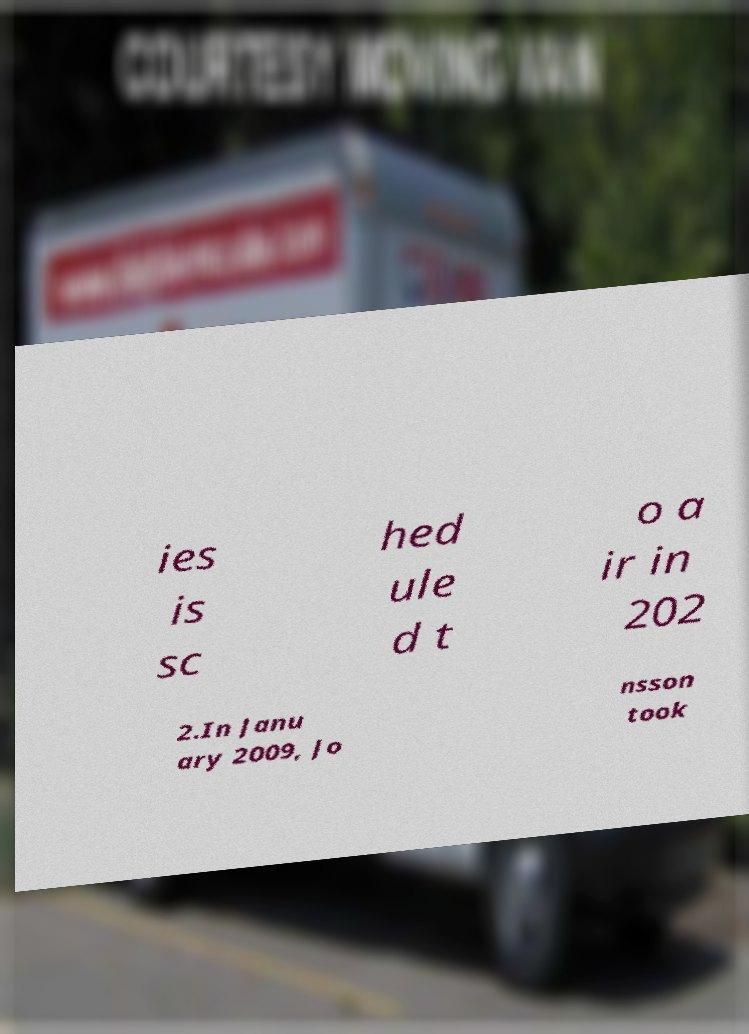Can you read and provide the text displayed in the image?This photo seems to have some interesting text. Can you extract and type it out for me? ies is sc hed ule d t o a ir in 202 2.In Janu ary 2009, Jo nsson took 